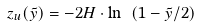<formula> <loc_0><loc_0><loc_500><loc_500>z _ { u } ( \tilde { y } ) = - 2 H \cdot \ln \ ( 1 - \tilde { y } / 2 )</formula> 